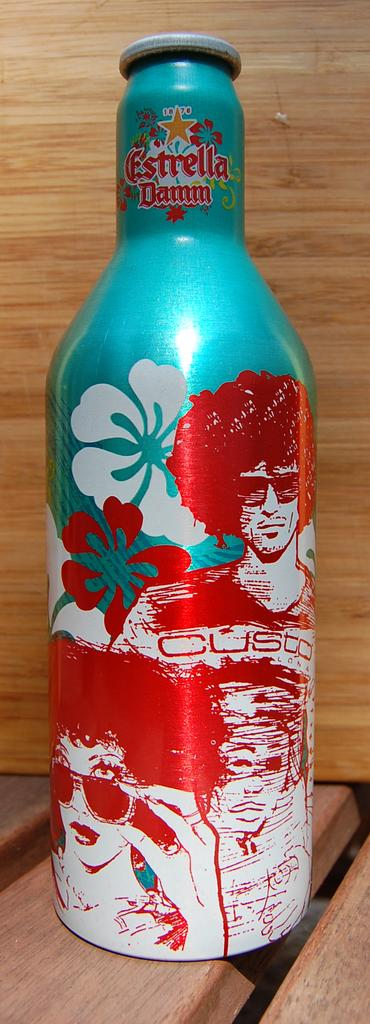Provide a one-sentence caption for the provided image. An Estrella drink bottle shows a colorful blue and red tropical scene. 